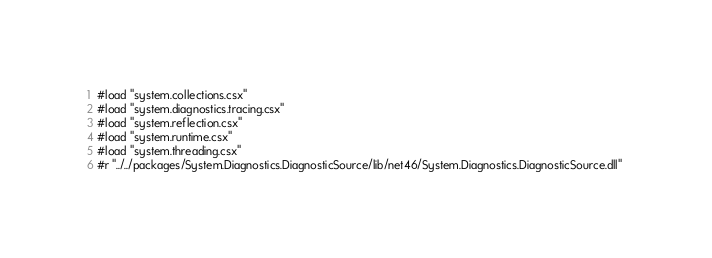<code> <loc_0><loc_0><loc_500><loc_500><_C#_>#load "system.collections.csx" 
#load "system.diagnostics.tracing.csx" 
#load "system.reflection.csx" 
#load "system.runtime.csx" 
#load "system.threading.csx" 
#r "../../packages/System.Diagnostics.DiagnosticSource/lib/net46/System.Diagnostics.DiagnosticSource.dll" </code> 